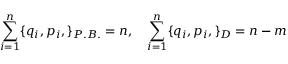Convert formula to latex. <formula><loc_0><loc_0><loc_500><loc_500>\sum _ { i = 1 } ^ { n } \{ q _ { i } , p _ { i } , \} _ { P . B . } = n , \quad \sum _ { i = 1 } ^ { n } \{ q _ { i } , p _ { i } , \} _ { D } = { n - m }</formula> 